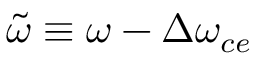Convert formula to latex. <formula><loc_0><loc_0><loc_500><loc_500>\tilde { \omega } \equiv \omega - \Delta \omega _ { c e }</formula> 